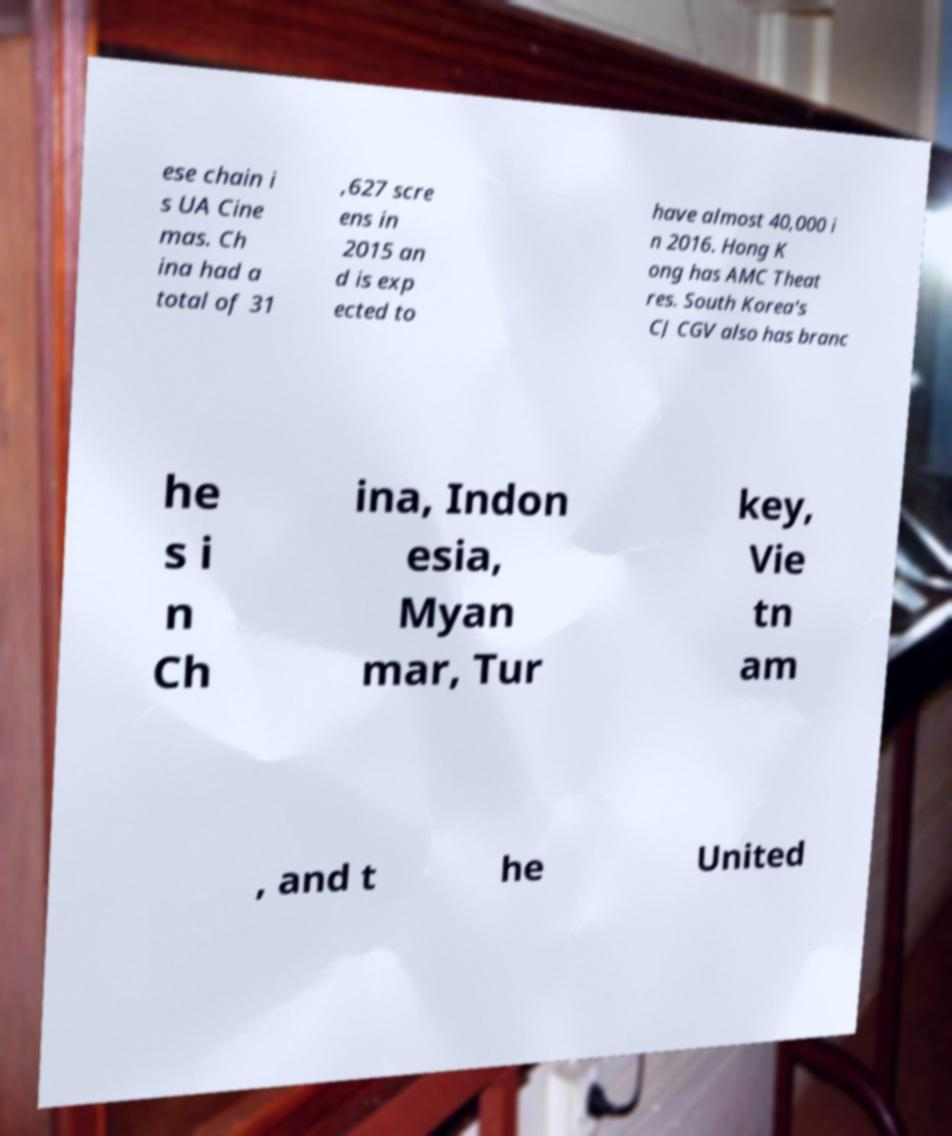Could you extract and type out the text from this image? ese chain i s UA Cine mas. Ch ina had a total of 31 ,627 scre ens in 2015 an d is exp ected to have almost 40,000 i n 2016. Hong K ong has AMC Theat res. South Korea's CJ CGV also has branc he s i n Ch ina, Indon esia, Myan mar, Tur key, Vie tn am , and t he United 